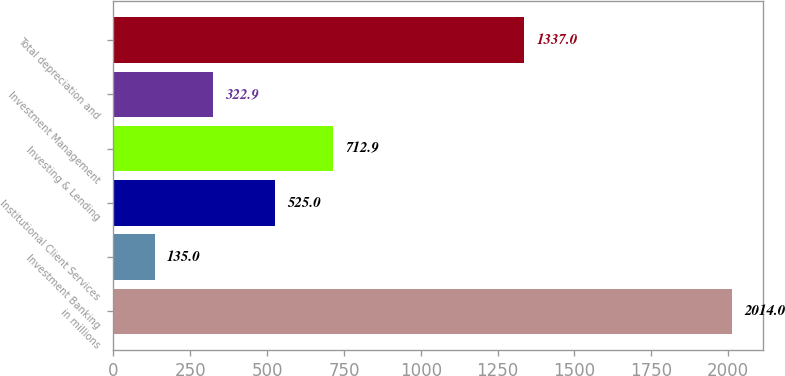<chart> <loc_0><loc_0><loc_500><loc_500><bar_chart><fcel>in millions<fcel>Investment Banking<fcel>Institutional Client Services<fcel>Investing & Lending<fcel>Investment Management<fcel>Total depreciation and<nl><fcel>2014<fcel>135<fcel>525<fcel>712.9<fcel>322.9<fcel>1337<nl></chart> 